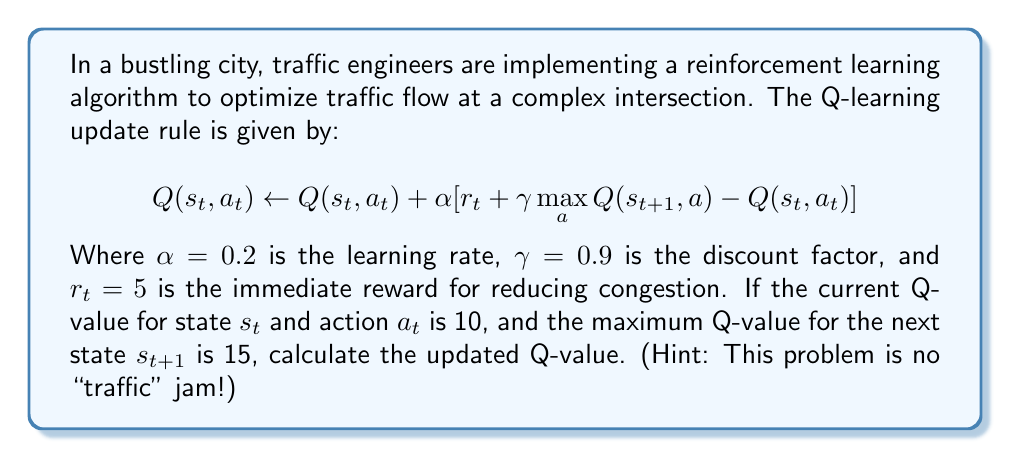Can you answer this question? Let's break down the solution step-by-step using the Q-learning update rule:

1) We're given:
   - $\alpha = 0.2$ (learning rate)
   - $\gamma = 0.9$ (discount factor)
   - $r_t = 5$ (immediate reward)
   - Current $Q(s_t, a_t) = 10$
   - $\max_{a} Q(s_{t+1}, a) = 15$

2) Let's substitute these values into the Q-learning update rule:

   $$ Q(s_t, a_t) \leftarrow 10 + 0.2 [5 + 0.9 \cdot 15 - 10] $$

3) First, let's calculate the value inside the square brackets:
   
   $5 + 0.9 \cdot 15 = 5 + 13.5 = 18.5$
   
   $18.5 - 10 = 8.5$

4) Now our equation looks like:

   $$ Q(s_t, a_t) \leftarrow 10 + 0.2 \cdot 8.5 $$

5) Calculate the final value:
   
   $0.2 \cdot 8.5 = 1.7$
   
   $10 + 1.7 = 11.7$

Therefore, the updated Q-value is 11.7.
Answer: $11.7$ 